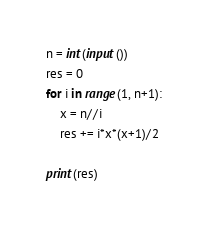Convert code to text. <code><loc_0><loc_0><loc_500><loc_500><_Python_>n = int(input())
res = 0
for i in range(1, n+1):
    x = n//i
    res += i*x*(x+1)/2
    
print(res)</code> 